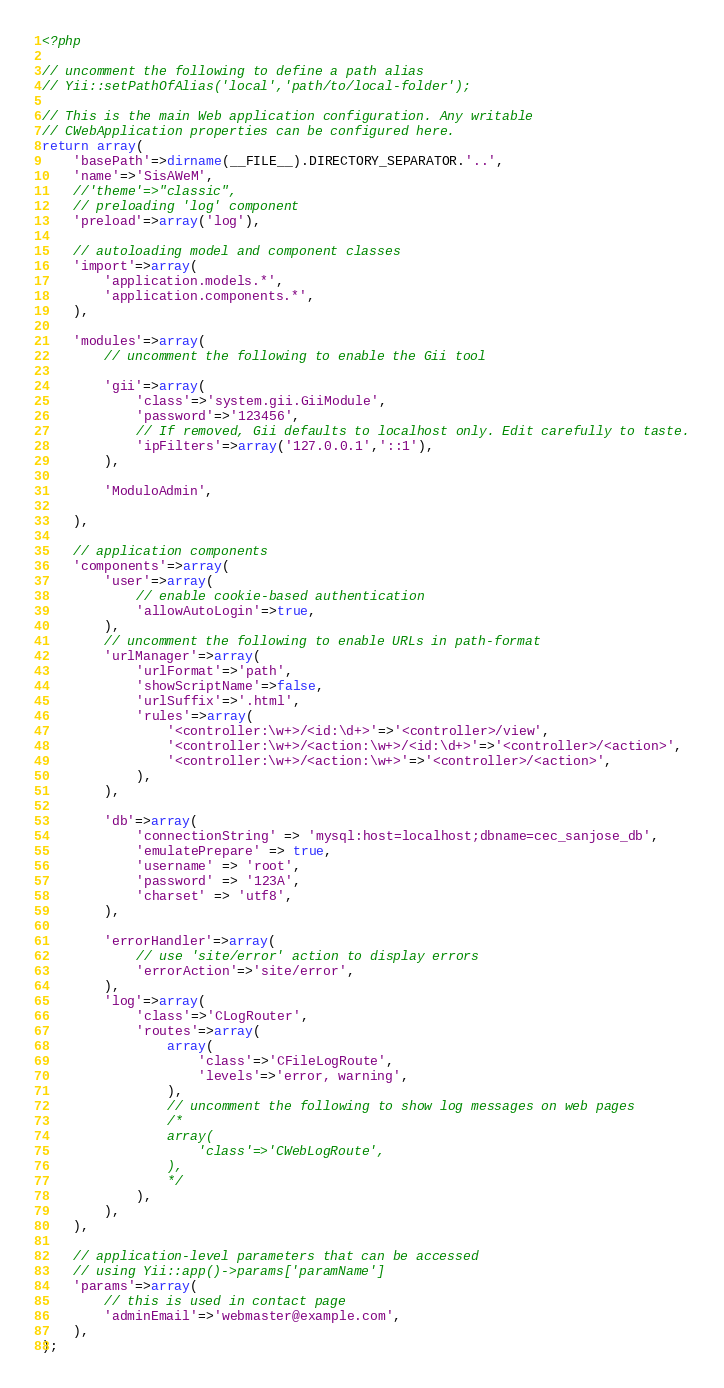Convert code to text. <code><loc_0><loc_0><loc_500><loc_500><_PHP_><?php

// uncomment the following to define a path alias
// Yii::setPathOfAlias('local','path/to/local-folder');

// This is the main Web application configuration. Any writable
// CWebApplication properties can be configured here.
return array(
	'basePath'=>dirname(__FILE__).DIRECTORY_SEPARATOR.'..',
	'name'=>'SisAWeM',
	//'theme'=>"classic",
	// preloading 'log' component
	'preload'=>array('log'),

	// autoloading model and component classes
	'import'=>array(
		'application.models.*',
		'application.components.*',
	),

	'modules'=>array(
		// uncomment the following to enable the Gii tool
	
		'gii'=>array(
			'class'=>'system.gii.GiiModule',
			'password'=>'123456',
			// If removed, Gii defaults to localhost only. Edit carefully to taste.
			'ipFilters'=>array('127.0.0.1','::1'),
		),
		
		'ModuloAdmin',
		
	),

	// application components
	'components'=>array(
		'user'=>array(
			// enable cookie-based authentication
			'allowAutoLogin'=>true,
		),
		// uncomment the following to enable URLs in path-format
		'urlManager'=>array(
			'urlFormat'=>'path',
			'showScriptName'=>false,
			'urlSuffix'=>'.html',
			'rules'=>array(
				'<controller:\w+>/<id:\d+>'=>'<controller>/view',
				'<controller:\w+>/<action:\w+>/<id:\d+>'=>'<controller>/<action>',
				'<controller:\w+>/<action:\w+>'=>'<controller>/<action>',
			),
		),
		
		'db'=>array(
			'connectionString' => 'mysql:host=localhost;dbname=cec_sanjose_db',
			'emulatePrepare' => true,
			'username' => 'root',
			'password' => '123A',
			'charset' => 'utf8',
		),
		
		'errorHandler'=>array(
			// use 'site/error' action to display errors
			'errorAction'=>'site/error',
		),
		'log'=>array(
			'class'=>'CLogRouter',
			'routes'=>array(
				array(
					'class'=>'CFileLogRoute',
					'levels'=>'error, warning',
				),
				// uncomment the following to show log messages on web pages
				/*
				array(
					'class'=>'CWebLogRoute',
				),
				*/
			),
		),
	),

	// application-level parameters that can be accessed
	// using Yii::app()->params['paramName']
	'params'=>array(
		// this is used in contact page
		'adminEmail'=>'webmaster@example.com',
	),
);</code> 